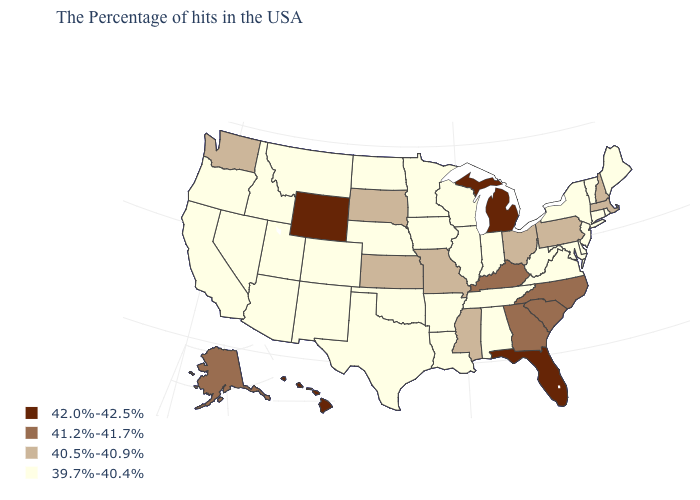Name the states that have a value in the range 39.7%-40.4%?
Quick response, please. Maine, Rhode Island, Vermont, Connecticut, New York, New Jersey, Delaware, Maryland, Virginia, West Virginia, Indiana, Alabama, Tennessee, Wisconsin, Illinois, Louisiana, Arkansas, Minnesota, Iowa, Nebraska, Oklahoma, Texas, North Dakota, Colorado, New Mexico, Utah, Montana, Arizona, Idaho, Nevada, California, Oregon. What is the value of Utah?
Write a very short answer. 39.7%-40.4%. Is the legend a continuous bar?
Keep it brief. No. Which states have the lowest value in the USA?
Concise answer only. Maine, Rhode Island, Vermont, Connecticut, New York, New Jersey, Delaware, Maryland, Virginia, West Virginia, Indiana, Alabama, Tennessee, Wisconsin, Illinois, Louisiana, Arkansas, Minnesota, Iowa, Nebraska, Oklahoma, Texas, North Dakota, Colorado, New Mexico, Utah, Montana, Arizona, Idaho, Nevada, California, Oregon. Name the states that have a value in the range 42.0%-42.5%?
Concise answer only. Florida, Michigan, Wyoming, Hawaii. Does Pennsylvania have the lowest value in the Northeast?
Answer briefly. No. Which states have the highest value in the USA?
Give a very brief answer. Florida, Michigan, Wyoming, Hawaii. Among the states that border Pennsylvania , does Ohio have the highest value?
Short answer required. Yes. What is the highest value in states that border Missouri?
Give a very brief answer. 41.2%-41.7%. Name the states that have a value in the range 39.7%-40.4%?
Quick response, please. Maine, Rhode Island, Vermont, Connecticut, New York, New Jersey, Delaware, Maryland, Virginia, West Virginia, Indiana, Alabama, Tennessee, Wisconsin, Illinois, Louisiana, Arkansas, Minnesota, Iowa, Nebraska, Oklahoma, Texas, North Dakota, Colorado, New Mexico, Utah, Montana, Arizona, Idaho, Nevada, California, Oregon. Name the states that have a value in the range 42.0%-42.5%?
Short answer required. Florida, Michigan, Wyoming, Hawaii. Name the states that have a value in the range 39.7%-40.4%?
Be succinct. Maine, Rhode Island, Vermont, Connecticut, New York, New Jersey, Delaware, Maryland, Virginia, West Virginia, Indiana, Alabama, Tennessee, Wisconsin, Illinois, Louisiana, Arkansas, Minnesota, Iowa, Nebraska, Oklahoma, Texas, North Dakota, Colorado, New Mexico, Utah, Montana, Arizona, Idaho, Nevada, California, Oregon. Does Tennessee have the lowest value in the USA?
Give a very brief answer. Yes. Name the states that have a value in the range 39.7%-40.4%?
Keep it brief. Maine, Rhode Island, Vermont, Connecticut, New York, New Jersey, Delaware, Maryland, Virginia, West Virginia, Indiana, Alabama, Tennessee, Wisconsin, Illinois, Louisiana, Arkansas, Minnesota, Iowa, Nebraska, Oklahoma, Texas, North Dakota, Colorado, New Mexico, Utah, Montana, Arizona, Idaho, Nevada, California, Oregon. Does Massachusetts have the lowest value in the USA?
Answer briefly. No. 